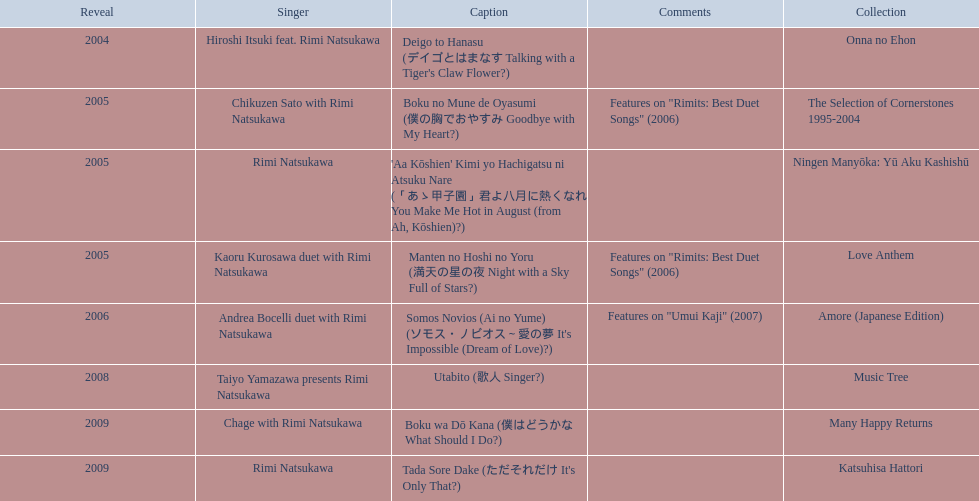How many titles have only one artist? 2. 